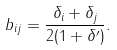<formula> <loc_0><loc_0><loc_500><loc_500>b _ { i j } = \frac { \delta _ { i } + \delta _ { j } } { 2 ( 1 + \delta ^ { \prime } ) } .</formula> 